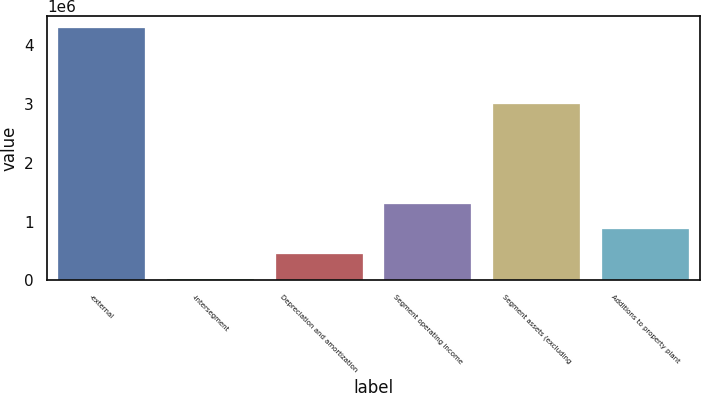Convert chart. <chart><loc_0><loc_0><loc_500><loc_500><bar_chart><fcel>-external<fcel>-intersegment<fcel>Depreciation and amortization<fcel>Segment operating income<fcel>Segment assets (excluding<fcel>Additions to property plant<nl><fcel>4.29206e+06<fcel>24485<fcel>451243<fcel>1.30476e+06<fcel>3.00512e+06<fcel>878001<nl></chart> 